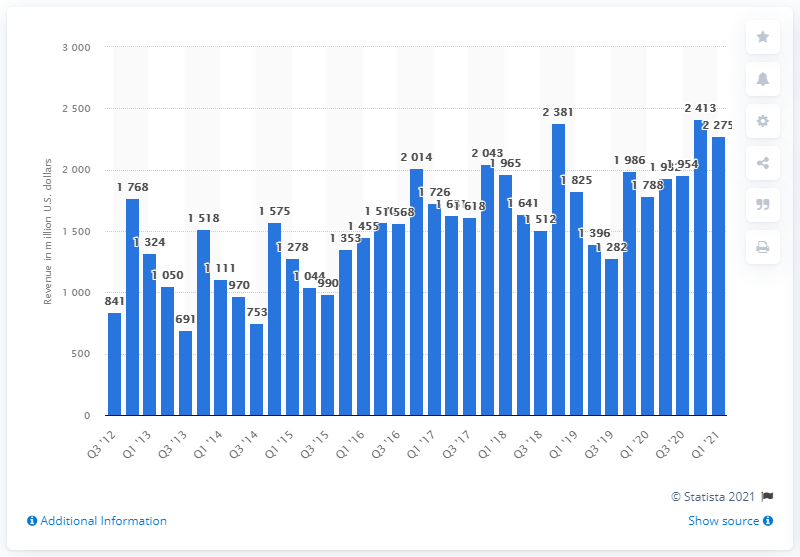Give some essential details in this illustration. Activision Blizzard's quarterly revenues in the first quarter of 2021 were approximately 2275. 